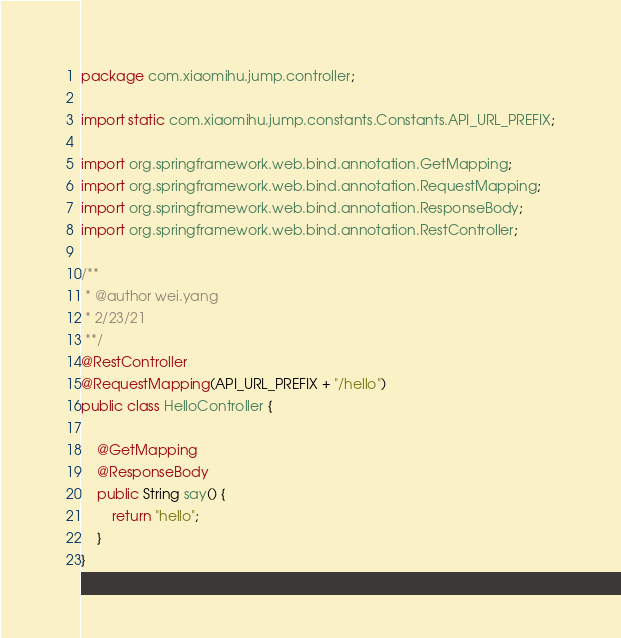<code> <loc_0><loc_0><loc_500><loc_500><_Java_>package com.xiaomihu.jump.controller;

import static com.xiaomihu.jump.constants.Constants.API_URL_PREFIX;

import org.springframework.web.bind.annotation.GetMapping;
import org.springframework.web.bind.annotation.RequestMapping;
import org.springframework.web.bind.annotation.ResponseBody;
import org.springframework.web.bind.annotation.RestController;

/**
 * @author wei.yang
 * 2/23/21
 **/
@RestController
@RequestMapping(API_URL_PREFIX + "/hello")
public class HelloController {

    @GetMapping
    @ResponseBody
    public String say() {
        return "hello";
    }
}</code> 